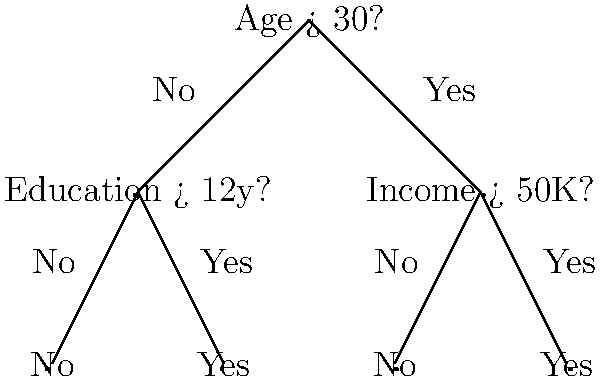Based on the decision tree diagram, what is the predicted outcome for a 35-year-old individual with 14 years of education and an annual income of $45,000? Let's traverse the decision tree step-by-step to determine the prediction:

1. The root node asks: "Age > 30?"
   Our individual is 35 years old, so the answer is Yes.
   We follow the "Yes" branch to the right.

2. The next node asks: "Income > 50K?"
   Our individual has an income of $45,000, which is less than $50,000.
   So the answer is No.
   We follow the "No" branch to the left.

3. We reach a leaf node labeled "No".

This leaf node represents the final prediction for our individual.
Answer: No 